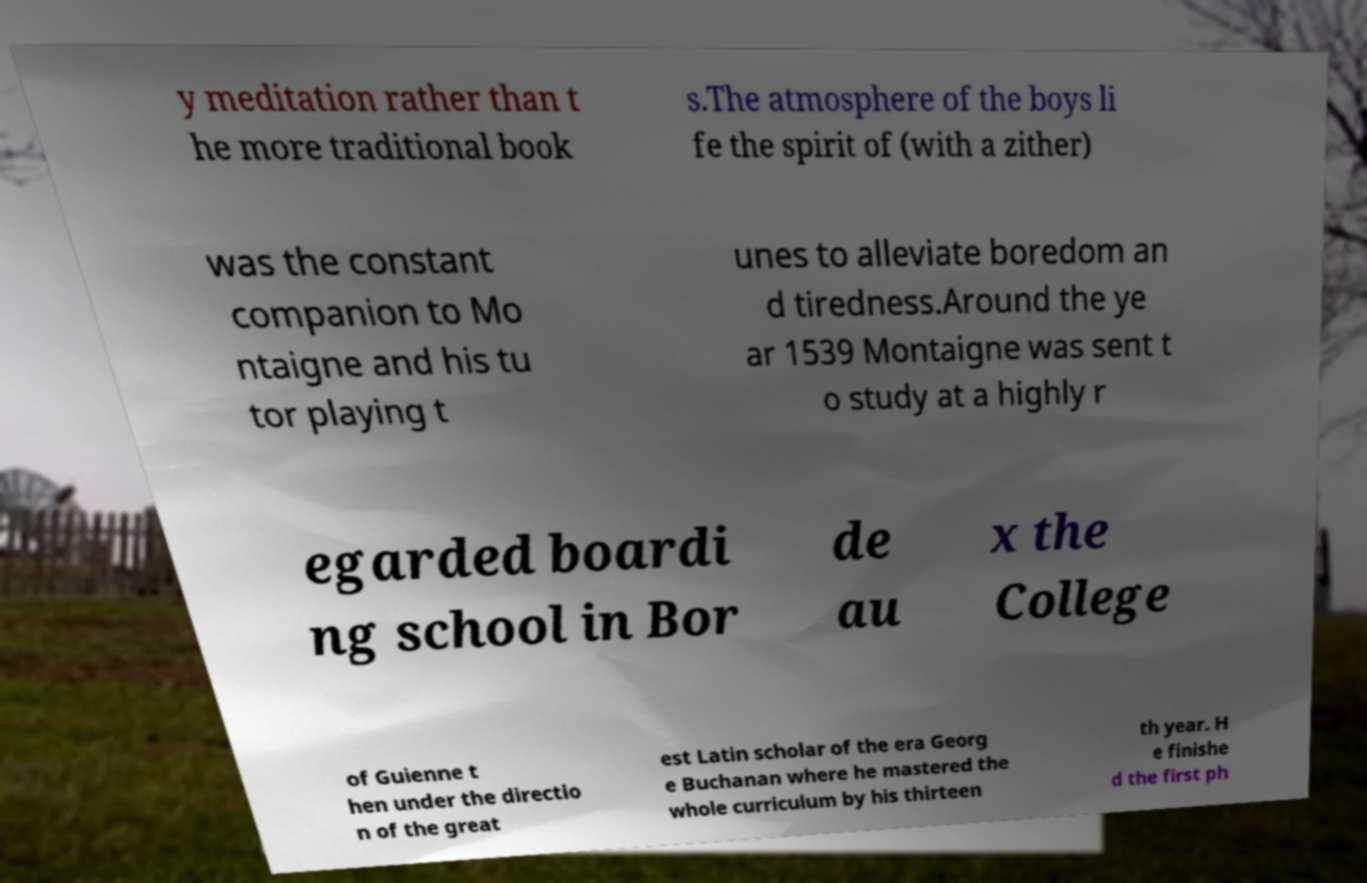I need the written content from this picture converted into text. Can you do that? y meditation rather than t he more traditional book s.The atmosphere of the boys li fe the spirit of (with a zither) was the constant companion to Mo ntaigne and his tu tor playing t unes to alleviate boredom an d tiredness.Around the ye ar 1539 Montaigne was sent t o study at a highly r egarded boardi ng school in Bor de au x the College of Guienne t hen under the directio n of the great est Latin scholar of the era Georg e Buchanan where he mastered the whole curriculum by his thirteen th year. H e finishe d the first ph 